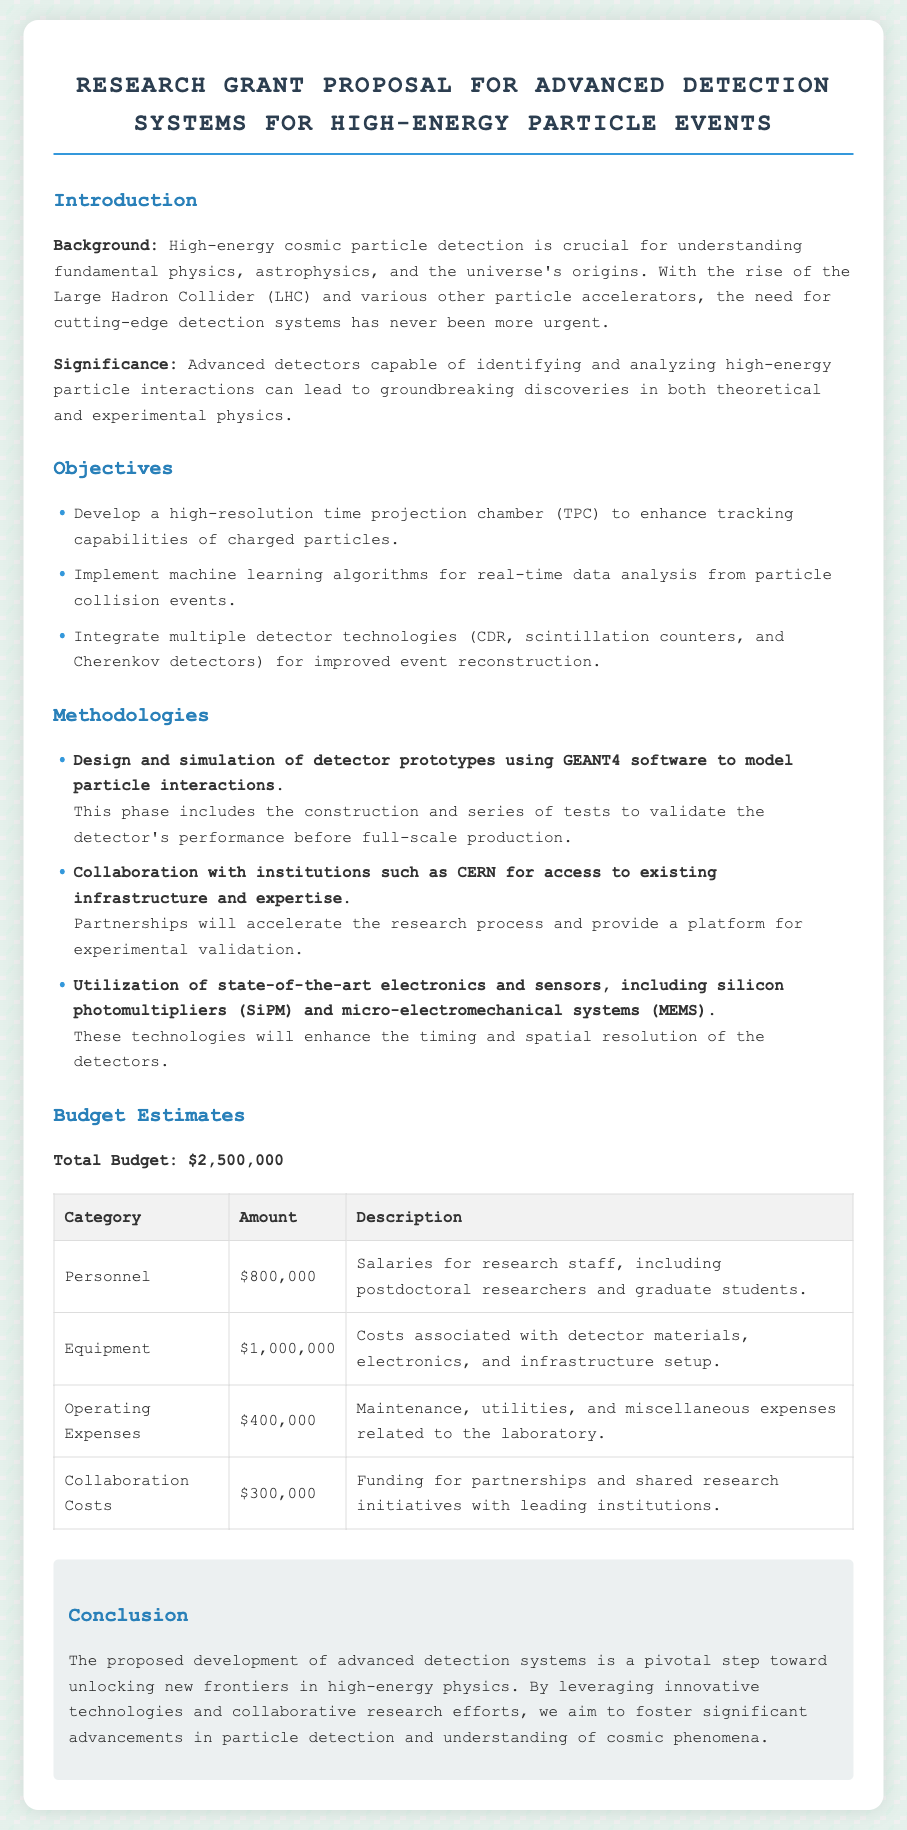What is the total budget for the proposal? The total budget is clearly stated in the proposal as $2,500,000.
Answer: $2,500,000 What is the primary aim of the proposed research? The introduction highlights the importance of detecting high-energy cosmic particles for understanding fundamental physics.
Answer: Understanding fundamental physics Which institution is mentioned for collaboration? The methodologies section specifies CERN as a key collaborating institution for the research project.
Answer: CERN How much is allocated for equipment costs? The budget table specifies that the amount allocated for equipment costs is $1,000,000.
Answer: $1,000,000 What detector technology is mentioned for enhancing spatial resolution? The methodologies section refers to silicon photomultipliers (SiPM) as an important technology for improving detection capabilities.
Answer: Silicon photomultipliers What is one of the goals regarding data analysis? The objectives emphasize implementing machine learning algorithms for real-time data analysis from particle collision events.
Answer: Machine learning algorithms How many categories are listed in the budget estimates? The budget section includes four distinct categories detailing expenses.
Answer: Four What will the development of advanced detection systems foster according to the conclusion? The conclusion states that the advancements aim to unlock new frontiers in high-energy physics.
Answer: New frontiers in high-energy physics 